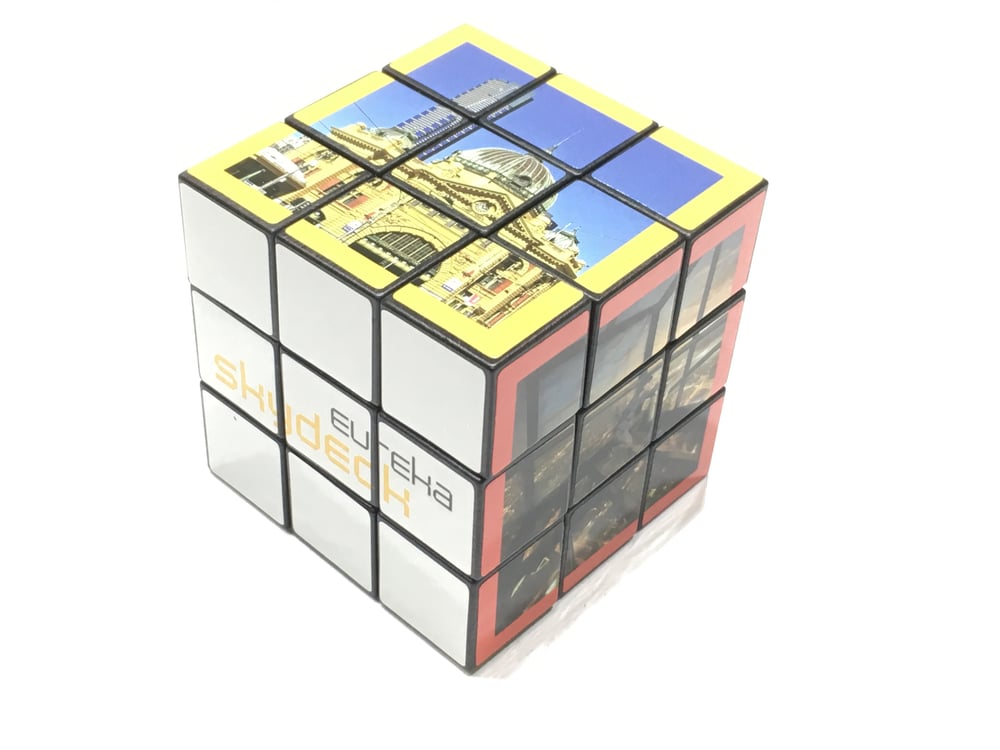If this cube was part of a treasure hunt, what kind of clues or instructions could it provide to the participants? If this cube was part of a treasure hunt, it could provide clues or instructions through its pictures and any visible text. Each side of the cube might feature images or words that participants must piece together to reveal the landmark's name or location. Instructions could be hidden within the design, such as specific items to look for in the landmark's vicinity. For example, the word 'SHINDECH' could be a code to decipher, leading to further clues or the treasure itself. Can you provide a very creative question about the cube and the potential landmark it represents? Imagine the dome atop this building could open like a telescope, revealing a portal to another world. What kind of world do you think lies beyond the structure, and how does the architecture of both worlds compare? Describe a realistic scenario where a person uses this cube to discover more about world-famous architectural landmarks. In a realistic scenario, a person fascinated by architecture might use this cube as a puzzle to test their knowledge of world-famous landmarks. As they solve the puzzle, each correctly aligned segment could reveal an image or clue about different parts of the building. This interactive process not only challenges their understanding of architectural styles but also encourages them to learn about the historical and cultural contexts of each landmark. The cube acts as an engaging educational tool, motivating the person to delve deeper into the rich heritage of the featured structures. Let's consider a short detailed scenario involving a historian using the cube. A historian, intrigued by the architectural images on the cube, begins rotating the segments to uncover each side's complete picture. As they align the puzzle correctly, they recognize features resembling well-known landmarks. With each turn, they annotate their discoveries, linking the architectural elements to specific styles and historical periods. This hands-on interaction with the cube serves as a practical exercise in identifying and appreciating the nuances of architectural history. 